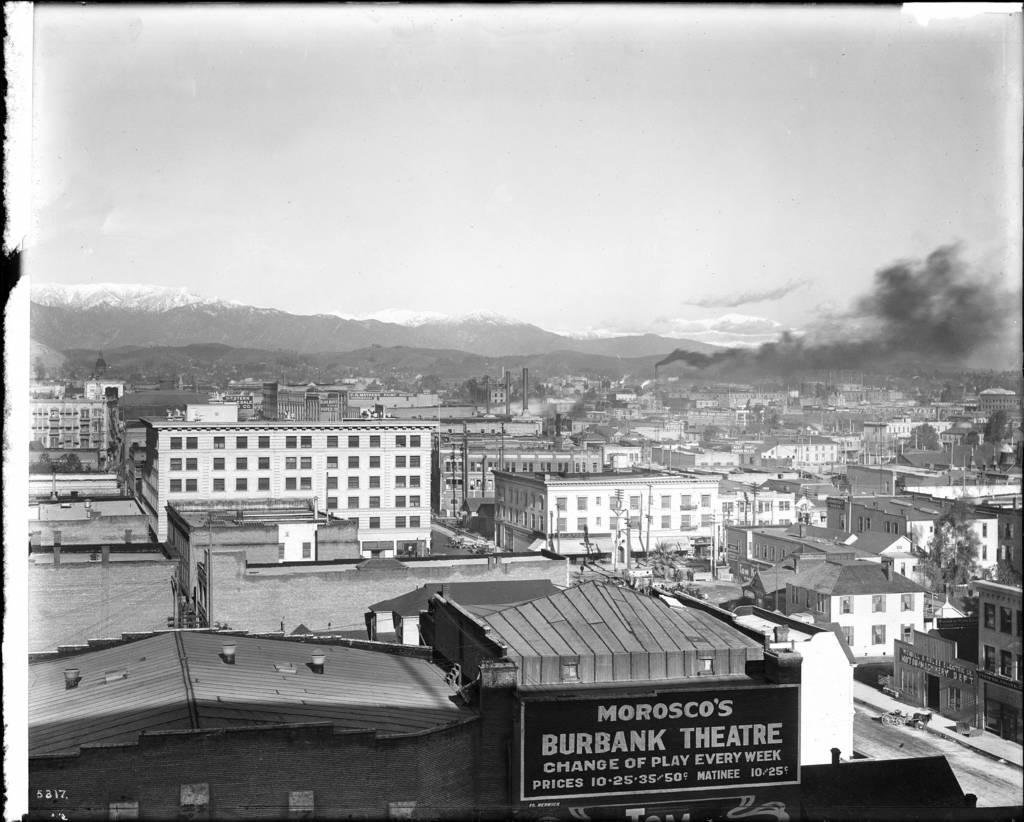Provide a one-sentence caption for the provided image. Morosco's burbank theatre sign is hanging on a building. 